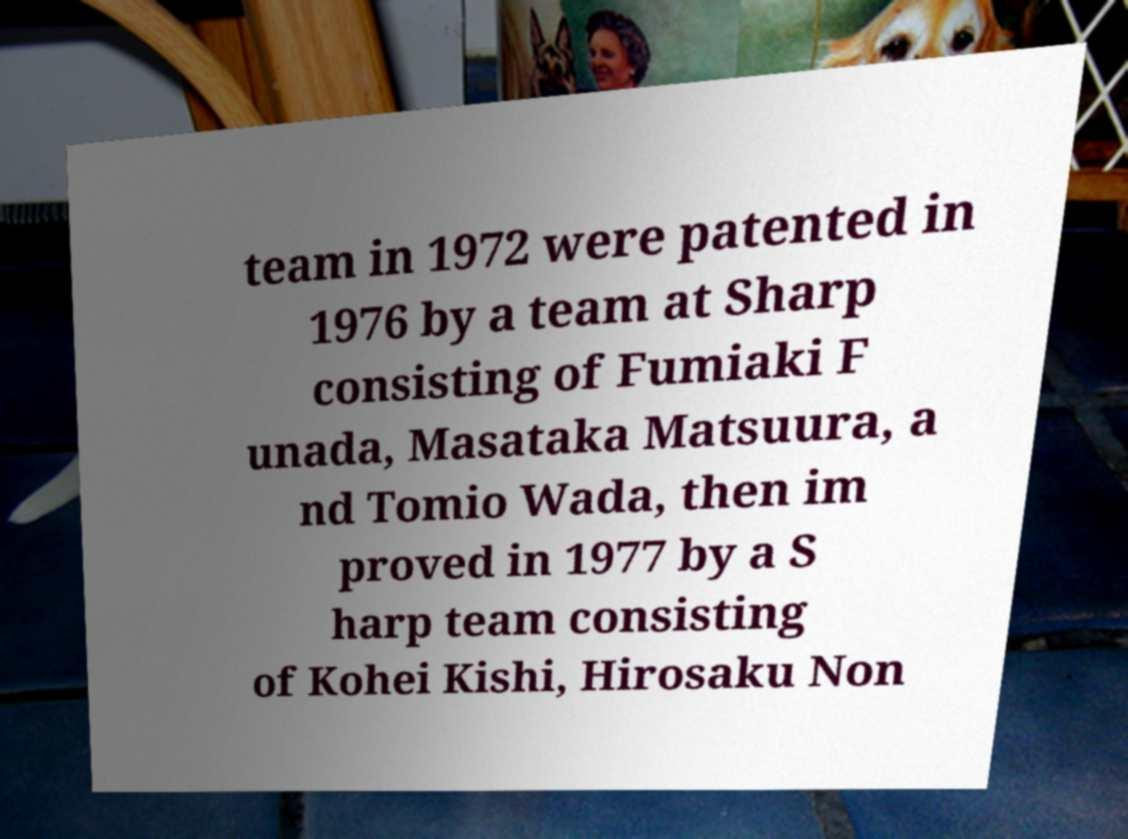What messages or text are displayed in this image? I need them in a readable, typed format. team in 1972 were patented in 1976 by a team at Sharp consisting of Fumiaki F unada, Masataka Matsuura, a nd Tomio Wada, then im proved in 1977 by a S harp team consisting of Kohei Kishi, Hirosaku Non 